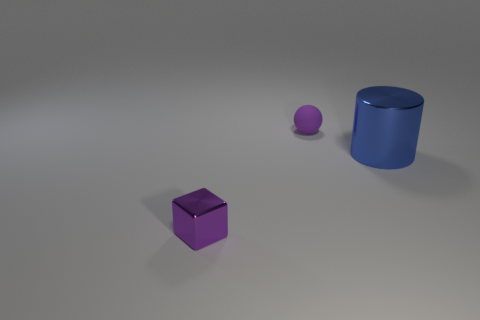Add 2 tiny metal things. How many objects exist? 5 Subtract 0 green blocks. How many objects are left? 3 Subtract all cubes. How many objects are left? 2 Subtract 1 blocks. How many blocks are left? 0 Subtract all red cubes. Subtract all green cylinders. How many cubes are left? 1 Subtract all tiny gray shiny blocks. Subtract all metallic things. How many objects are left? 1 Add 2 matte spheres. How many matte spheres are left? 3 Add 1 shiny blocks. How many shiny blocks exist? 2 